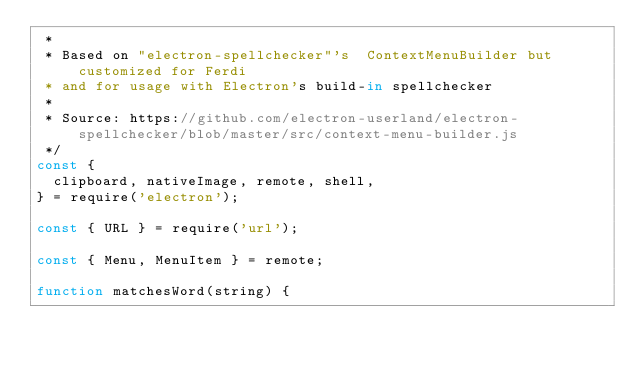<code> <loc_0><loc_0><loc_500><loc_500><_JavaScript_> *
 * Based on "electron-spellchecker"'s  ContextMenuBuilder but customized for Ferdi
 * and for usage with Electron's build-in spellchecker
 *
 * Source: https://github.com/electron-userland/electron-spellchecker/blob/master/src/context-menu-builder.js
 */
const {
  clipboard, nativeImage, remote, shell,
} = require('electron');

const { URL } = require('url');

const { Menu, MenuItem } = remote;

function matchesWord(string) {</code> 